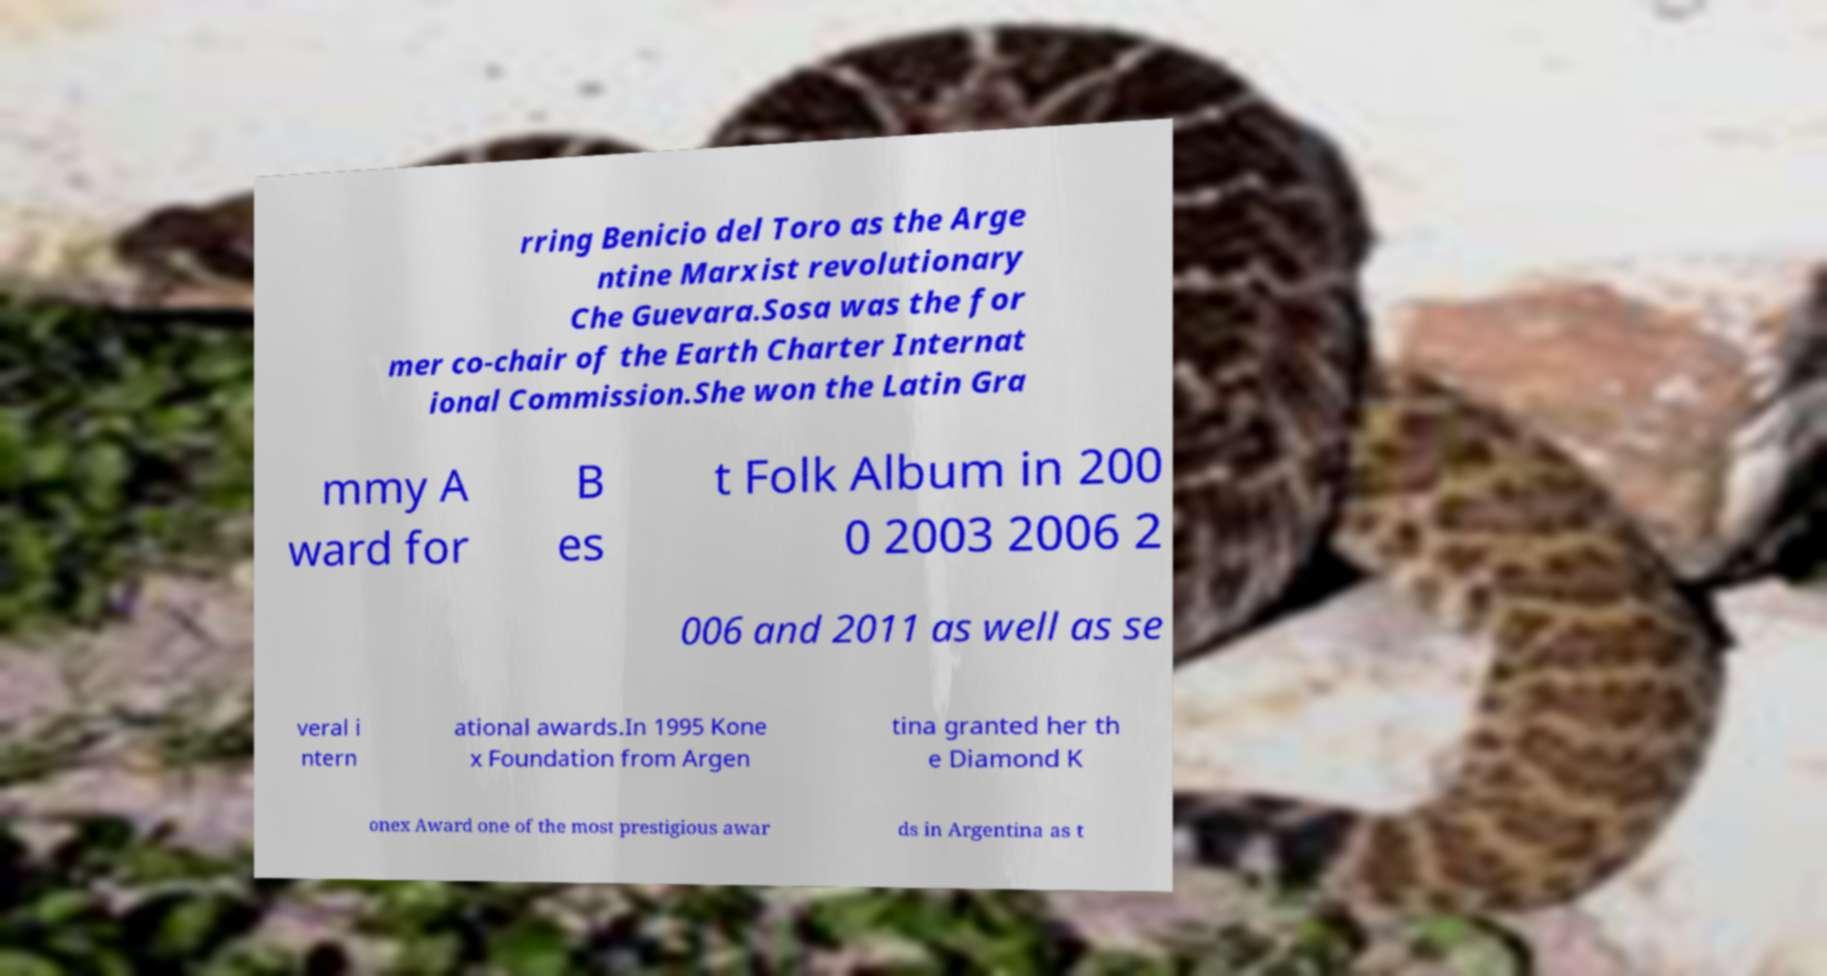Please identify and transcribe the text found in this image. rring Benicio del Toro as the Arge ntine Marxist revolutionary Che Guevara.Sosa was the for mer co-chair of the Earth Charter Internat ional Commission.She won the Latin Gra mmy A ward for B es t Folk Album in 200 0 2003 2006 2 006 and 2011 as well as se veral i ntern ational awards.In 1995 Kone x Foundation from Argen tina granted her th e Diamond K onex Award one of the most prestigious awar ds in Argentina as t 